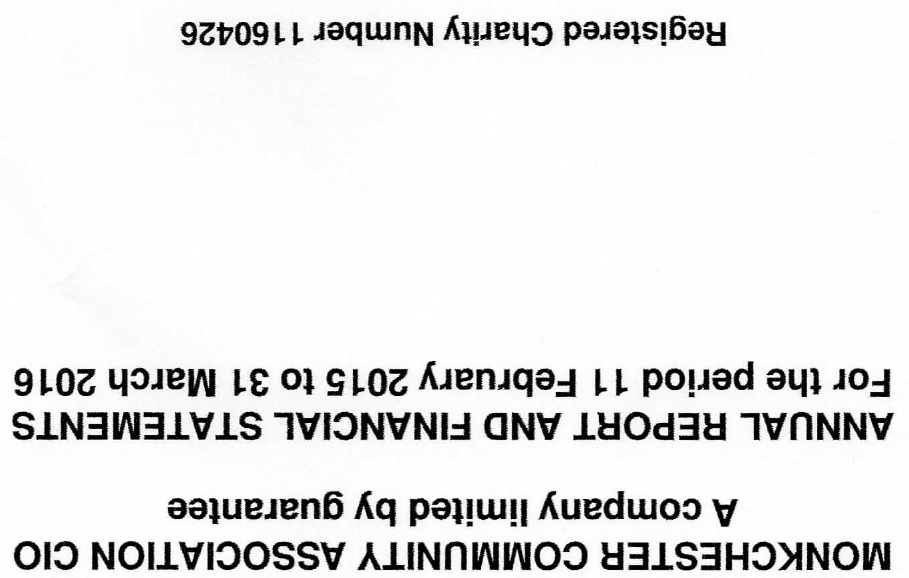What is the value for the report_date?
Answer the question using a single word or phrase. 2016-03-31 